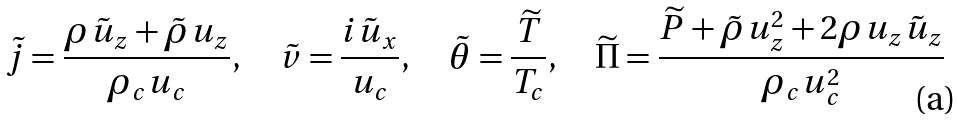Convert formula to latex. <formula><loc_0><loc_0><loc_500><loc_500>\tilde { j } = { \frac { { \rho \tilde { u } _ { z } + \tilde { \rho } u _ { z } } } { { \rho _ { c } u _ { c } } } } , \quad \tilde { v } = { \frac { { i \tilde { u } _ { x } } } { { u _ { c } } } } , \quad \tilde { \theta } = { \frac { { \widetilde { T } } } { { T _ { c } } } } , \quad \widetilde { \Pi } = { \frac { { \widetilde { P } + \tilde { \rho } u _ { z } ^ { 2 } + 2 \rho u _ { z } \tilde { u } _ { z } } } { { \rho _ { c } u _ { c } ^ { 2 } } } }</formula> 